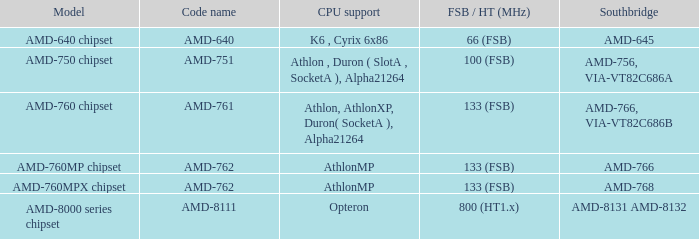What are the code names for the southbridge when it appears as amd-766 and via-vt82c686b? AMD-761. 